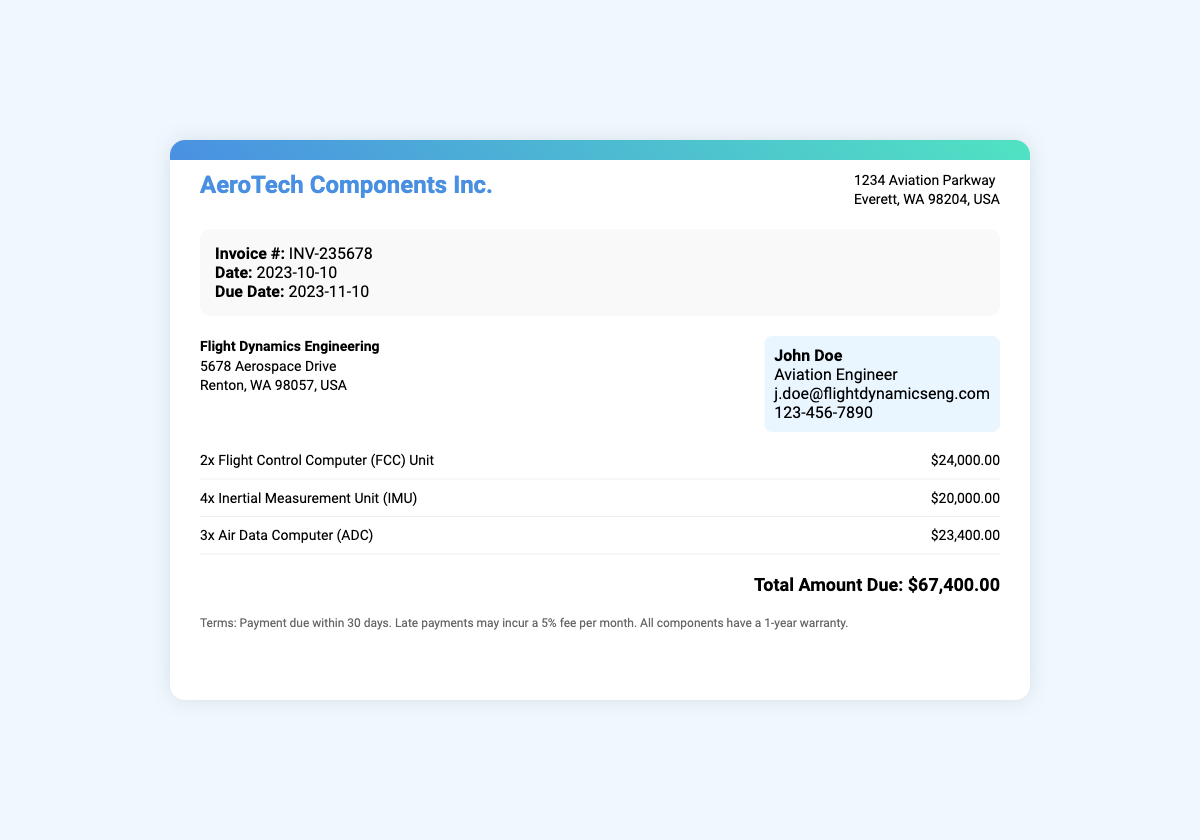What is the invoice number? The invoice number is specifically mentioned in the document as INV-235678.
Answer: INV-235678 What is the total amount due? The total amount due is clearly stated in the total section of the document as $67,400.00.
Answer: $67,400.00 Who is the contact person for Flight Dynamics Engineering? The contact person is John Doe, as listed in the customer info section.
Answer: John Doe How many Air Data Computer (ADC) Units are included in the invoice? The document specifies that there are 3 units of Air Data Computer (ADC).
Answer: 3 What is the due date for the invoice? The due date is provided in the invoice details, stated as 2023-11-10.
Answer: 2023-11-10 What is the warranty period for all components? The document mentions that all components have a 1-year warranty.
Answer: 1-year What date was the invoice issued? The invoice date is explicitly mentioned as 2023-10-10.
Answer: 2023-10-10 How many Inertial Measurement Units (IMU) are on the invoice? The number of Inertial Measurement Units (IMU) is listed as 4 in the items section.
Answer: 4 What is the payment term for the invoice? The payment term states that payment is due within 30 days.
Answer: 30 days 